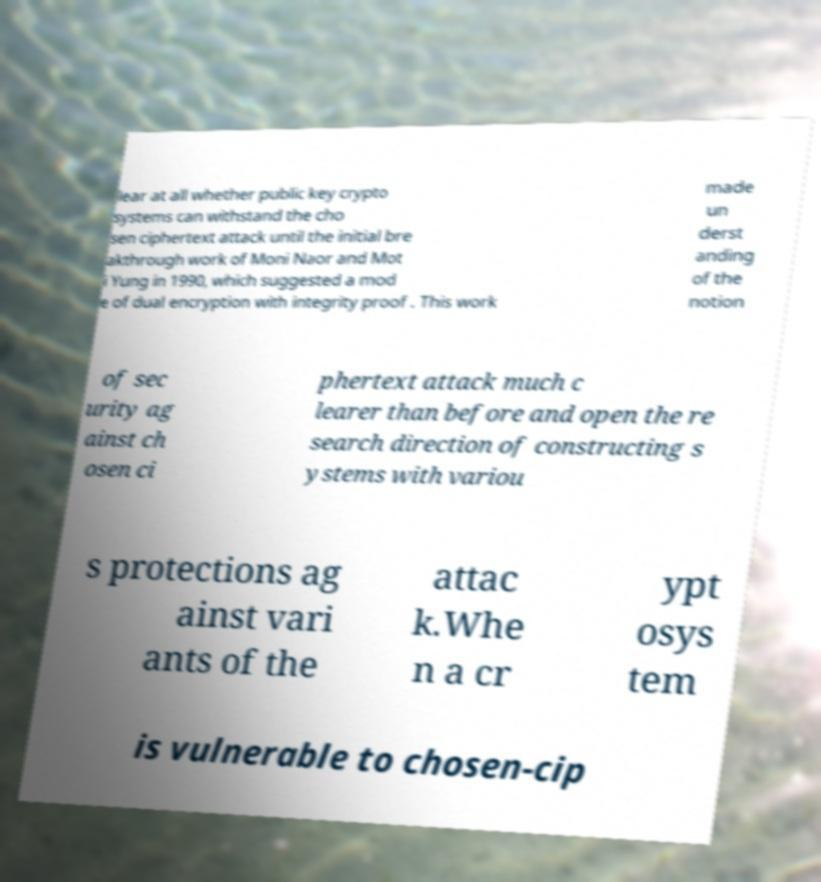Please identify and transcribe the text found in this image. lear at all whether public key crypto systems can withstand the cho sen ciphertext attack until the initial bre akthrough work of Moni Naor and Mot i Yung in 1990, which suggested a mod e of dual encryption with integrity proof . This work made un derst anding of the notion of sec urity ag ainst ch osen ci phertext attack much c learer than before and open the re search direction of constructing s ystems with variou s protections ag ainst vari ants of the attac k.Whe n a cr ypt osys tem is vulnerable to chosen-cip 